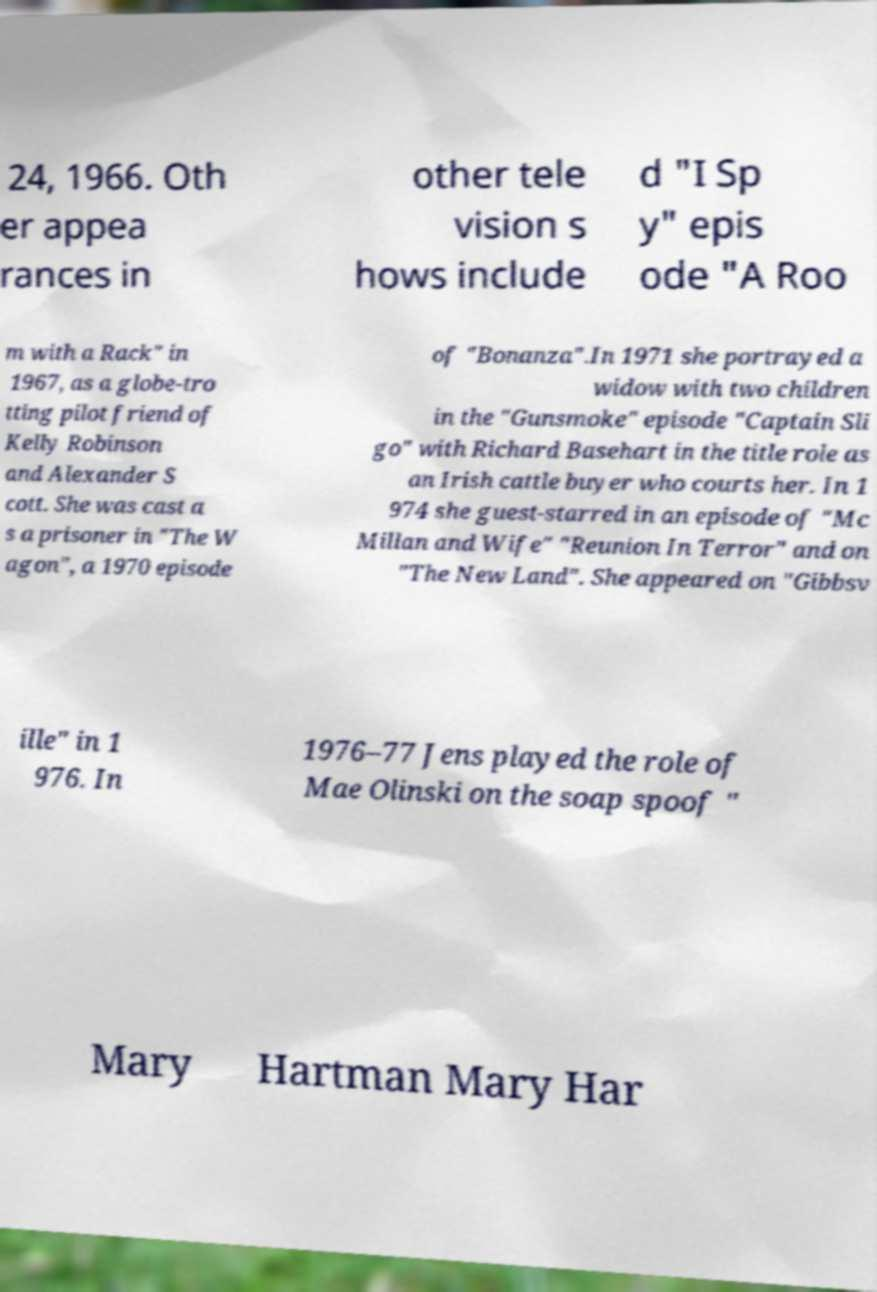I need the written content from this picture converted into text. Can you do that? 24, 1966. Oth er appea rances in other tele vision s hows include d "I Sp y" epis ode "A Roo m with a Rack" in 1967, as a globe-tro tting pilot friend of Kelly Robinson and Alexander S cott. She was cast a s a prisoner in "The W agon", a 1970 episode of "Bonanza".In 1971 she portrayed a widow with two children in the "Gunsmoke" episode "Captain Sli go" with Richard Basehart in the title role as an Irish cattle buyer who courts her. In 1 974 she guest-starred in an episode of "Mc Millan and Wife" "Reunion In Terror" and on "The New Land". She appeared on "Gibbsv ille" in 1 976. In 1976–77 Jens played the role of Mae Olinski on the soap spoof " Mary Hartman Mary Har 